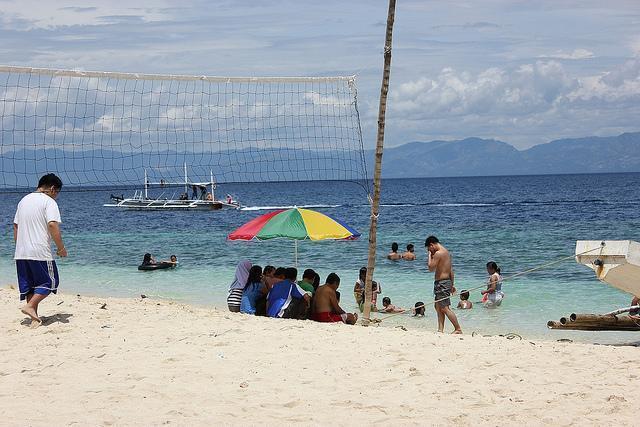How many umbrellas do you see?
Give a very brief answer. 1. How many boats are in the water?
Give a very brief answer. 1. How many umbrellas are in the picture?
Give a very brief answer. 1. How many people can you see?
Give a very brief answer. 2. How many boats are in the photo?
Give a very brief answer. 2. How many legs is the bear standing on?
Give a very brief answer. 0. 